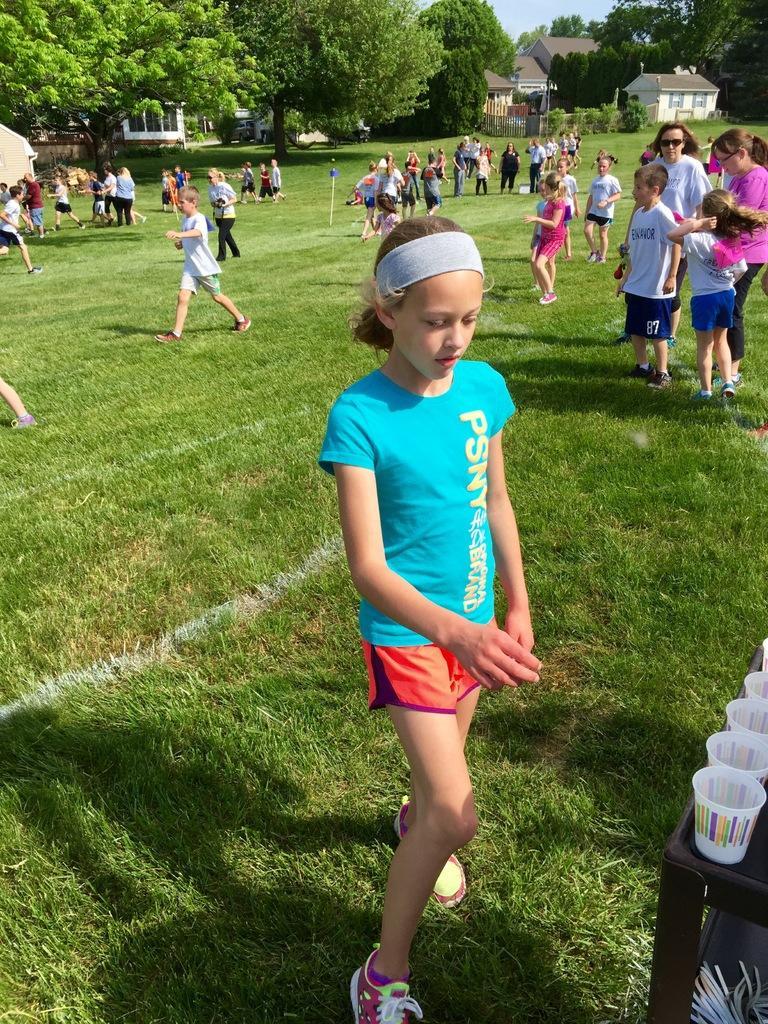Describe this image in one or two sentences. In this picture I can observe some people walking on the land. There are children in this picture. In the background there are trees and houses. 